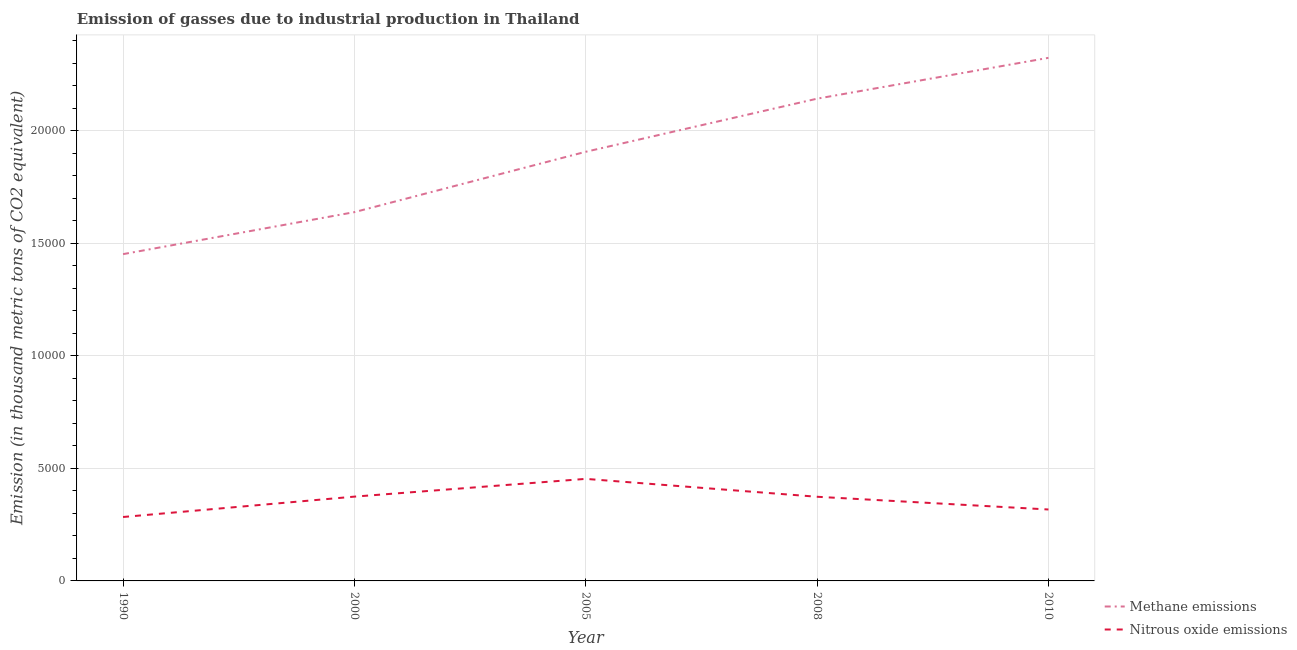How many different coloured lines are there?
Offer a terse response. 2. Is the number of lines equal to the number of legend labels?
Your answer should be very brief. Yes. What is the amount of methane emissions in 1990?
Your answer should be compact. 1.45e+04. Across all years, what is the maximum amount of methane emissions?
Offer a terse response. 2.32e+04. Across all years, what is the minimum amount of nitrous oxide emissions?
Keep it short and to the point. 2838.9. In which year was the amount of nitrous oxide emissions maximum?
Offer a terse response. 2005. What is the total amount of methane emissions in the graph?
Your answer should be very brief. 9.46e+04. What is the difference between the amount of nitrous oxide emissions in 1990 and that in 2010?
Make the answer very short. -333.5. What is the difference between the amount of nitrous oxide emissions in 2008 and the amount of methane emissions in 2005?
Provide a short and direct response. -1.53e+04. What is the average amount of nitrous oxide emissions per year?
Offer a terse response. 3605.06. In the year 2000, what is the difference between the amount of nitrous oxide emissions and amount of methane emissions?
Make the answer very short. -1.26e+04. What is the ratio of the amount of methane emissions in 1990 to that in 2008?
Offer a very short reply. 0.68. What is the difference between the highest and the second highest amount of nitrous oxide emissions?
Keep it short and to the point. 788.7. What is the difference between the highest and the lowest amount of nitrous oxide emissions?
Your answer should be very brief. 1693.5. Does the amount of nitrous oxide emissions monotonically increase over the years?
Give a very brief answer. No. Is the amount of methane emissions strictly less than the amount of nitrous oxide emissions over the years?
Give a very brief answer. No. How many years are there in the graph?
Give a very brief answer. 5. Are the values on the major ticks of Y-axis written in scientific E-notation?
Make the answer very short. No. Does the graph contain any zero values?
Provide a succinct answer. No. Does the graph contain grids?
Offer a terse response. Yes. How many legend labels are there?
Give a very brief answer. 2. How are the legend labels stacked?
Provide a succinct answer. Vertical. What is the title of the graph?
Offer a very short reply. Emission of gasses due to industrial production in Thailand. What is the label or title of the Y-axis?
Keep it short and to the point. Emission (in thousand metric tons of CO2 equivalent). What is the Emission (in thousand metric tons of CO2 equivalent) of Methane emissions in 1990?
Offer a terse response. 1.45e+04. What is the Emission (in thousand metric tons of CO2 equivalent) of Nitrous oxide emissions in 1990?
Keep it short and to the point. 2838.9. What is the Emission (in thousand metric tons of CO2 equivalent) of Methane emissions in 2000?
Offer a very short reply. 1.64e+04. What is the Emission (in thousand metric tons of CO2 equivalent) in Nitrous oxide emissions in 2000?
Offer a very short reply. 3743.7. What is the Emission (in thousand metric tons of CO2 equivalent) in Methane emissions in 2005?
Provide a succinct answer. 1.91e+04. What is the Emission (in thousand metric tons of CO2 equivalent) in Nitrous oxide emissions in 2005?
Offer a very short reply. 4532.4. What is the Emission (in thousand metric tons of CO2 equivalent) in Methane emissions in 2008?
Make the answer very short. 2.14e+04. What is the Emission (in thousand metric tons of CO2 equivalent) of Nitrous oxide emissions in 2008?
Offer a terse response. 3737.9. What is the Emission (in thousand metric tons of CO2 equivalent) of Methane emissions in 2010?
Keep it short and to the point. 2.32e+04. What is the Emission (in thousand metric tons of CO2 equivalent) in Nitrous oxide emissions in 2010?
Offer a terse response. 3172.4. Across all years, what is the maximum Emission (in thousand metric tons of CO2 equivalent) of Methane emissions?
Keep it short and to the point. 2.32e+04. Across all years, what is the maximum Emission (in thousand metric tons of CO2 equivalent) in Nitrous oxide emissions?
Make the answer very short. 4532.4. Across all years, what is the minimum Emission (in thousand metric tons of CO2 equivalent) of Methane emissions?
Offer a terse response. 1.45e+04. Across all years, what is the minimum Emission (in thousand metric tons of CO2 equivalent) of Nitrous oxide emissions?
Offer a terse response. 2838.9. What is the total Emission (in thousand metric tons of CO2 equivalent) in Methane emissions in the graph?
Your answer should be very brief. 9.46e+04. What is the total Emission (in thousand metric tons of CO2 equivalent) of Nitrous oxide emissions in the graph?
Keep it short and to the point. 1.80e+04. What is the difference between the Emission (in thousand metric tons of CO2 equivalent) in Methane emissions in 1990 and that in 2000?
Keep it short and to the point. -1865.4. What is the difference between the Emission (in thousand metric tons of CO2 equivalent) in Nitrous oxide emissions in 1990 and that in 2000?
Your answer should be compact. -904.8. What is the difference between the Emission (in thousand metric tons of CO2 equivalent) in Methane emissions in 1990 and that in 2005?
Provide a short and direct response. -4546.4. What is the difference between the Emission (in thousand metric tons of CO2 equivalent) of Nitrous oxide emissions in 1990 and that in 2005?
Offer a very short reply. -1693.5. What is the difference between the Emission (in thousand metric tons of CO2 equivalent) of Methane emissions in 1990 and that in 2008?
Offer a terse response. -6904.8. What is the difference between the Emission (in thousand metric tons of CO2 equivalent) of Nitrous oxide emissions in 1990 and that in 2008?
Keep it short and to the point. -899. What is the difference between the Emission (in thousand metric tons of CO2 equivalent) of Methane emissions in 1990 and that in 2010?
Your answer should be very brief. -8718.6. What is the difference between the Emission (in thousand metric tons of CO2 equivalent) of Nitrous oxide emissions in 1990 and that in 2010?
Keep it short and to the point. -333.5. What is the difference between the Emission (in thousand metric tons of CO2 equivalent) of Methane emissions in 2000 and that in 2005?
Your answer should be very brief. -2681. What is the difference between the Emission (in thousand metric tons of CO2 equivalent) in Nitrous oxide emissions in 2000 and that in 2005?
Provide a succinct answer. -788.7. What is the difference between the Emission (in thousand metric tons of CO2 equivalent) in Methane emissions in 2000 and that in 2008?
Offer a very short reply. -5039.4. What is the difference between the Emission (in thousand metric tons of CO2 equivalent) in Nitrous oxide emissions in 2000 and that in 2008?
Your answer should be very brief. 5.8. What is the difference between the Emission (in thousand metric tons of CO2 equivalent) in Methane emissions in 2000 and that in 2010?
Keep it short and to the point. -6853.2. What is the difference between the Emission (in thousand metric tons of CO2 equivalent) in Nitrous oxide emissions in 2000 and that in 2010?
Offer a very short reply. 571.3. What is the difference between the Emission (in thousand metric tons of CO2 equivalent) of Methane emissions in 2005 and that in 2008?
Offer a very short reply. -2358.4. What is the difference between the Emission (in thousand metric tons of CO2 equivalent) of Nitrous oxide emissions in 2005 and that in 2008?
Give a very brief answer. 794.5. What is the difference between the Emission (in thousand metric tons of CO2 equivalent) of Methane emissions in 2005 and that in 2010?
Your answer should be very brief. -4172.2. What is the difference between the Emission (in thousand metric tons of CO2 equivalent) of Nitrous oxide emissions in 2005 and that in 2010?
Keep it short and to the point. 1360. What is the difference between the Emission (in thousand metric tons of CO2 equivalent) in Methane emissions in 2008 and that in 2010?
Your answer should be compact. -1813.8. What is the difference between the Emission (in thousand metric tons of CO2 equivalent) in Nitrous oxide emissions in 2008 and that in 2010?
Make the answer very short. 565.5. What is the difference between the Emission (in thousand metric tons of CO2 equivalent) of Methane emissions in 1990 and the Emission (in thousand metric tons of CO2 equivalent) of Nitrous oxide emissions in 2000?
Provide a short and direct response. 1.08e+04. What is the difference between the Emission (in thousand metric tons of CO2 equivalent) in Methane emissions in 1990 and the Emission (in thousand metric tons of CO2 equivalent) in Nitrous oxide emissions in 2005?
Keep it short and to the point. 9981.2. What is the difference between the Emission (in thousand metric tons of CO2 equivalent) in Methane emissions in 1990 and the Emission (in thousand metric tons of CO2 equivalent) in Nitrous oxide emissions in 2008?
Your answer should be very brief. 1.08e+04. What is the difference between the Emission (in thousand metric tons of CO2 equivalent) in Methane emissions in 1990 and the Emission (in thousand metric tons of CO2 equivalent) in Nitrous oxide emissions in 2010?
Make the answer very short. 1.13e+04. What is the difference between the Emission (in thousand metric tons of CO2 equivalent) of Methane emissions in 2000 and the Emission (in thousand metric tons of CO2 equivalent) of Nitrous oxide emissions in 2005?
Your answer should be very brief. 1.18e+04. What is the difference between the Emission (in thousand metric tons of CO2 equivalent) of Methane emissions in 2000 and the Emission (in thousand metric tons of CO2 equivalent) of Nitrous oxide emissions in 2008?
Your answer should be very brief. 1.26e+04. What is the difference between the Emission (in thousand metric tons of CO2 equivalent) in Methane emissions in 2000 and the Emission (in thousand metric tons of CO2 equivalent) in Nitrous oxide emissions in 2010?
Offer a very short reply. 1.32e+04. What is the difference between the Emission (in thousand metric tons of CO2 equivalent) of Methane emissions in 2005 and the Emission (in thousand metric tons of CO2 equivalent) of Nitrous oxide emissions in 2008?
Keep it short and to the point. 1.53e+04. What is the difference between the Emission (in thousand metric tons of CO2 equivalent) of Methane emissions in 2005 and the Emission (in thousand metric tons of CO2 equivalent) of Nitrous oxide emissions in 2010?
Offer a very short reply. 1.59e+04. What is the difference between the Emission (in thousand metric tons of CO2 equivalent) in Methane emissions in 2008 and the Emission (in thousand metric tons of CO2 equivalent) in Nitrous oxide emissions in 2010?
Your response must be concise. 1.82e+04. What is the average Emission (in thousand metric tons of CO2 equivalent) in Methane emissions per year?
Offer a terse response. 1.89e+04. What is the average Emission (in thousand metric tons of CO2 equivalent) of Nitrous oxide emissions per year?
Offer a very short reply. 3605.06. In the year 1990, what is the difference between the Emission (in thousand metric tons of CO2 equivalent) of Methane emissions and Emission (in thousand metric tons of CO2 equivalent) of Nitrous oxide emissions?
Offer a terse response. 1.17e+04. In the year 2000, what is the difference between the Emission (in thousand metric tons of CO2 equivalent) in Methane emissions and Emission (in thousand metric tons of CO2 equivalent) in Nitrous oxide emissions?
Provide a succinct answer. 1.26e+04. In the year 2005, what is the difference between the Emission (in thousand metric tons of CO2 equivalent) of Methane emissions and Emission (in thousand metric tons of CO2 equivalent) of Nitrous oxide emissions?
Your answer should be compact. 1.45e+04. In the year 2008, what is the difference between the Emission (in thousand metric tons of CO2 equivalent) in Methane emissions and Emission (in thousand metric tons of CO2 equivalent) in Nitrous oxide emissions?
Ensure brevity in your answer.  1.77e+04. In the year 2010, what is the difference between the Emission (in thousand metric tons of CO2 equivalent) of Methane emissions and Emission (in thousand metric tons of CO2 equivalent) of Nitrous oxide emissions?
Offer a terse response. 2.01e+04. What is the ratio of the Emission (in thousand metric tons of CO2 equivalent) in Methane emissions in 1990 to that in 2000?
Provide a succinct answer. 0.89. What is the ratio of the Emission (in thousand metric tons of CO2 equivalent) in Nitrous oxide emissions in 1990 to that in 2000?
Offer a terse response. 0.76. What is the ratio of the Emission (in thousand metric tons of CO2 equivalent) in Methane emissions in 1990 to that in 2005?
Provide a short and direct response. 0.76. What is the ratio of the Emission (in thousand metric tons of CO2 equivalent) in Nitrous oxide emissions in 1990 to that in 2005?
Keep it short and to the point. 0.63. What is the ratio of the Emission (in thousand metric tons of CO2 equivalent) of Methane emissions in 1990 to that in 2008?
Provide a succinct answer. 0.68. What is the ratio of the Emission (in thousand metric tons of CO2 equivalent) in Nitrous oxide emissions in 1990 to that in 2008?
Make the answer very short. 0.76. What is the ratio of the Emission (in thousand metric tons of CO2 equivalent) of Methane emissions in 1990 to that in 2010?
Keep it short and to the point. 0.62. What is the ratio of the Emission (in thousand metric tons of CO2 equivalent) of Nitrous oxide emissions in 1990 to that in 2010?
Offer a terse response. 0.89. What is the ratio of the Emission (in thousand metric tons of CO2 equivalent) in Methane emissions in 2000 to that in 2005?
Keep it short and to the point. 0.86. What is the ratio of the Emission (in thousand metric tons of CO2 equivalent) in Nitrous oxide emissions in 2000 to that in 2005?
Provide a succinct answer. 0.83. What is the ratio of the Emission (in thousand metric tons of CO2 equivalent) in Methane emissions in 2000 to that in 2008?
Make the answer very short. 0.76. What is the ratio of the Emission (in thousand metric tons of CO2 equivalent) in Nitrous oxide emissions in 2000 to that in 2008?
Offer a terse response. 1. What is the ratio of the Emission (in thousand metric tons of CO2 equivalent) in Methane emissions in 2000 to that in 2010?
Provide a short and direct response. 0.7. What is the ratio of the Emission (in thousand metric tons of CO2 equivalent) of Nitrous oxide emissions in 2000 to that in 2010?
Ensure brevity in your answer.  1.18. What is the ratio of the Emission (in thousand metric tons of CO2 equivalent) in Methane emissions in 2005 to that in 2008?
Offer a terse response. 0.89. What is the ratio of the Emission (in thousand metric tons of CO2 equivalent) of Nitrous oxide emissions in 2005 to that in 2008?
Your answer should be compact. 1.21. What is the ratio of the Emission (in thousand metric tons of CO2 equivalent) of Methane emissions in 2005 to that in 2010?
Offer a terse response. 0.82. What is the ratio of the Emission (in thousand metric tons of CO2 equivalent) in Nitrous oxide emissions in 2005 to that in 2010?
Provide a succinct answer. 1.43. What is the ratio of the Emission (in thousand metric tons of CO2 equivalent) in Methane emissions in 2008 to that in 2010?
Make the answer very short. 0.92. What is the ratio of the Emission (in thousand metric tons of CO2 equivalent) in Nitrous oxide emissions in 2008 to that in 2010?
Make the answer very short. 1.18. What is the difference between the highest and the second highest Emission (in thousand metric tons of CO2 equivalent) in Methane emissions?
Make the answer very short. 1813.8. What is the difference between the highest and the second highest Emission (in thousand metric tons of CO2 equivalent) in Nitrous oxide emissions?
Your answer should be compact. 788.7. What is the difference between the highest and the lowest Emission (in thousand metric tons of CO2 equivalent) of Methane emissions?
Keep it short and to the point. 8718.6. What is the difference between the highest and the lowest Emission (in thousand metric tons of CO2 equivalent) of Nitrous oxide emissions?
Your response must be concise. 1693.5. 